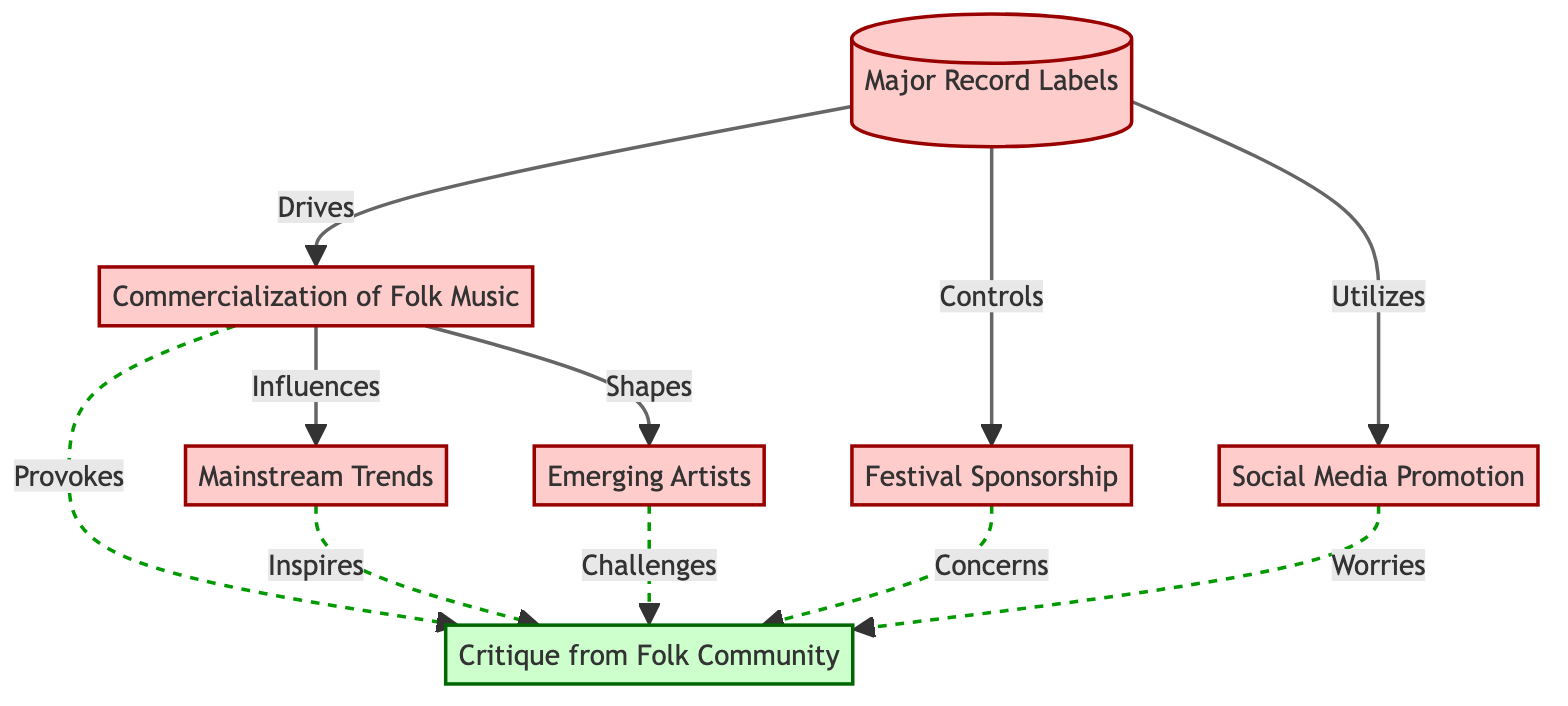What is the main influence of Major Record Labels on folk music? Major Record Labels drive the commercialization of folk music, indicating their significant influence on the genre.
Answer: commercialization of folk music How many nodes are present in the diagram? Counting each distinct element listed, there are seven nodes represented in the diagram.
Answer: 7 Which element is influenced by the Commercialization of Folk Music? The diagram shows that both Mainstream Trends and Emerging Artists are influenced by the Commercialization of Folk Music.
Answer: Mainstream Trends, Emerging Artists What kind of relationship exists between Commercialization of Folk Music and Critique from Folk Community? The diagram indicates a dashed line relationship, meaning that commercial influences often provoke concerns among the folk community, suggesting a critical perspective.
Answer: provokes What actions do Major Record Labels control at festivals? According to the diagram, Major Record Labels control Festival Sponsorship, impacting artist promotions and festival line-ups.
Answer: Festival Sponsorship Which node displays the concerns of the folk community in response to mainstream trends? The Critique from Folk Community displays concerns specifically in response to the influences of Mainstream Trends, highlighting backlash from purists.
Answer: Critique from Folk Community How many influences does Commercialization of Folk Music exert? The Commercialization of Folk Music influences three elements in total: Mainstream Trends, Emerging Artists, and it provokes Critique from the Folk Community.
Answer: 3 What kind of promotion do record labels utilize? Social Media Promotion is identified in the diagram, illustrating that record labels use platforms for marketing folk artists.
Answer: Social Media Promotion What is the term for new folk musicians groomed by record labels? Emerging Artists represent new folk musicians shaped to fit market demands rather than following traditional creative paths.
Answer: Emerging Artists 